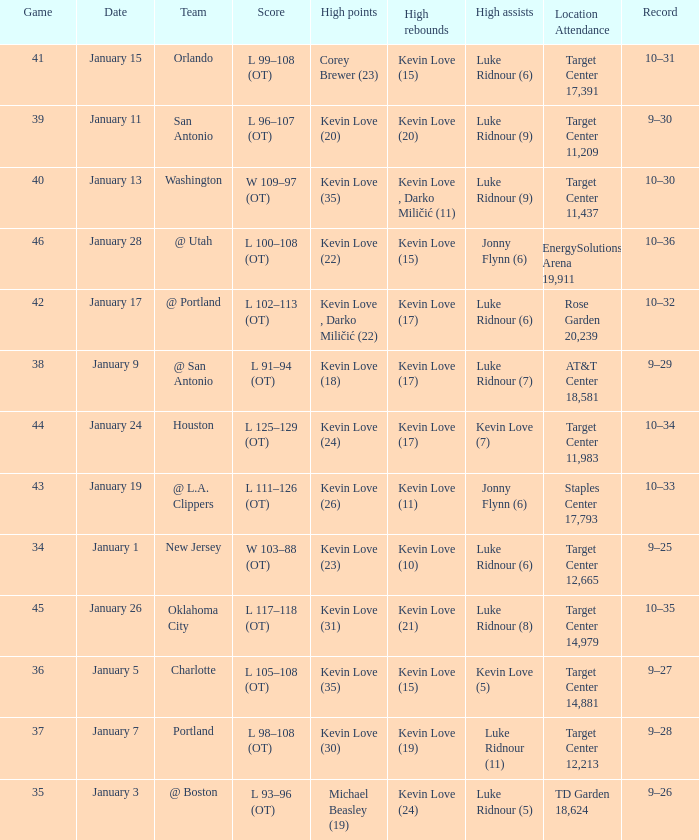Help me parse the entirety of this table. {'header': ['Game', 'Date', 'Team', 'Score', 'High points', 'High rebounds', 'High assists', 'Location Attendance', 'Record'], 'rows': [['41', 'January 15', 'Orlando', 'L 99–108 (OT)', 'Corey Brewer (23)', 'Kevin Love (15)', 'Luke Ridnour (6)', 'Target Center 17,391', '10–31'], ['39', 'January 11', 'San Antonio', 'L 96–107 (OT)', 'Kevin Love (20)', 'Kevin Love (20)', 'Luke Ridnour (9)', 'Target Center 11,209', '9–30'], ['40', 'January 13', 'Washington', 'W 109–97 (OT)', 'Kevin Love (35)', 'Kevin Love , Darko Miličić (11)', 'Luke Ridnour (9)', 'Target Center 11,437', '10–30'], ['46', 'January 28', '@ Utah', 'L 100–108 (OT)', 'Kevin Love (22)', 'Kevin Love (15)', 'Jonny Flynn (6)', 'EnergySolutions Arena 19,911', '10–36'], ['42', 'January 17', '@ Portland', 'L 102–113 (OT)', 'Kevin Love , Darko Miličić (22)', 'Kevin Love (17)', 'Luke Ridnour (6)', 'Rose Garden 20,239', '10–32'], ['38', 'January 9', '@ San Antonio', 'L 91–94 (OT)', 'Kevin Love (18)', 'Kevin Love (17)', 'Luke Ridnour (7)', 'AT&T Center 18,581', '9–29'], ['44', 'January 24', 'Houston', 'L 125–129 (OT)', 'Kevin Love (24)', 'Kevin Love (17)', 'Kevin Love (7)', 'Target Center 11,983', '10–34'], ['43', 'January 19', '@ L.A. Clippers', 'L 111–126 (OT)', 'Kevin Love (26)', 'Kevin Love (11)', 'Jonny Flynn (6)', 'Staples Center 17,793', '10–33'], ['34', 'January 1', 'New Jersey', 'W 103–88 (OT)', 'Kevin Love (23)', 'Kevin Love (10)', 'Luke Ridnour (6)', 'Target Center 12,665', '9–25'], ['45', 'January 26', 'Oklahoma City', 'L 117–118 (OT)', 'Kevin Love (31)', 'Kevin Love (21)', 'Luke Ridnour (8)', 'Target Center 14,979', '10–35'], ['36', 'January 5', 'Charlotte', 'L 105–108 (OT)', 'Kevin Love (35)', 'Kevin Love (15)', 'Kevin Love (5)', 'Target Center 14,881', '9–27'], ['37', 'January 7', 'Portland', 'L 98–108 (OT)', 'Kevin Love (30)', 'Kevin Love (19)', 'Luke Ridnour (11)', 'Target Center 12,213', '9–28'], ['35', 'January 3', '@ Boston', 'L 93–96 (OT)', 'Michael Beasley (19)', 'Kevin Love (24)', 'Luke Ridnour (5)', 'TD Garden 18,624', '9–26']]} What is the highest game with team @ l.a. clippers? 43.0. 